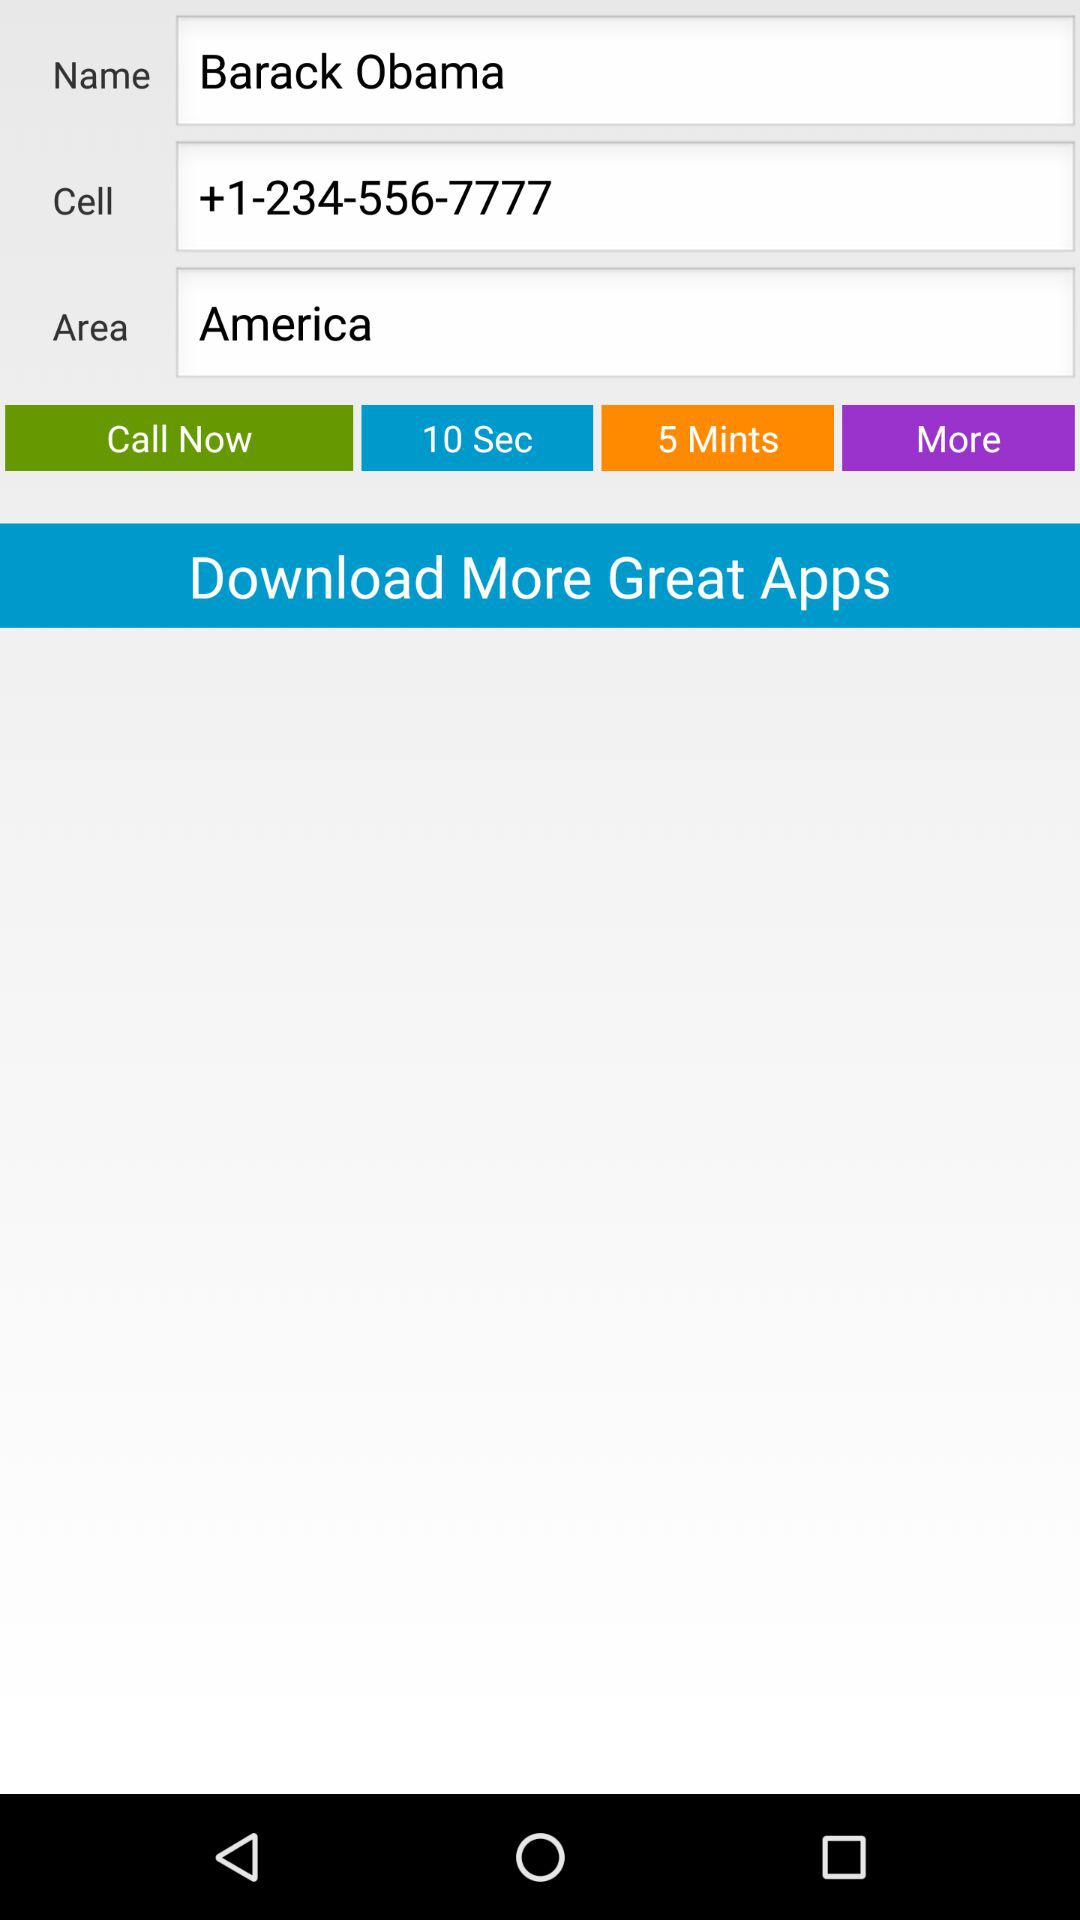What is the area? The area is America. 